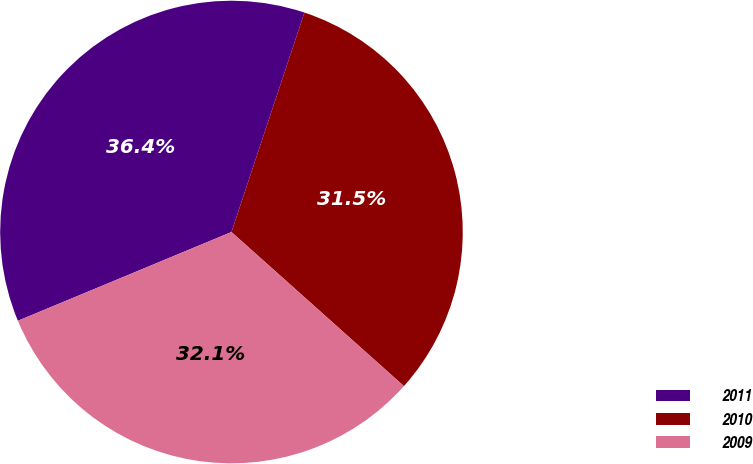<chart> <loc_0><loc_0><loc_500><loc_500><pie_chart><fcel>2011<fcel>2010<fcel>2009<nl><fcel>36.38%<fcel>31.5%<fcel>32.13%<nl></chart> 